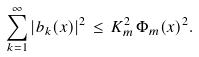Convert formula to latex. <formula><loc_0><loc_0><loc_500><loc_500>\sum _ { k = 1 } ^ { \infty } \left | b _ { k } ( x ) \right | ^ { 2 } \, \leq \, K _ { m } ^ { 2 } \, \Phi _ { m } ( x ) ^ { 2 } .</formula> 